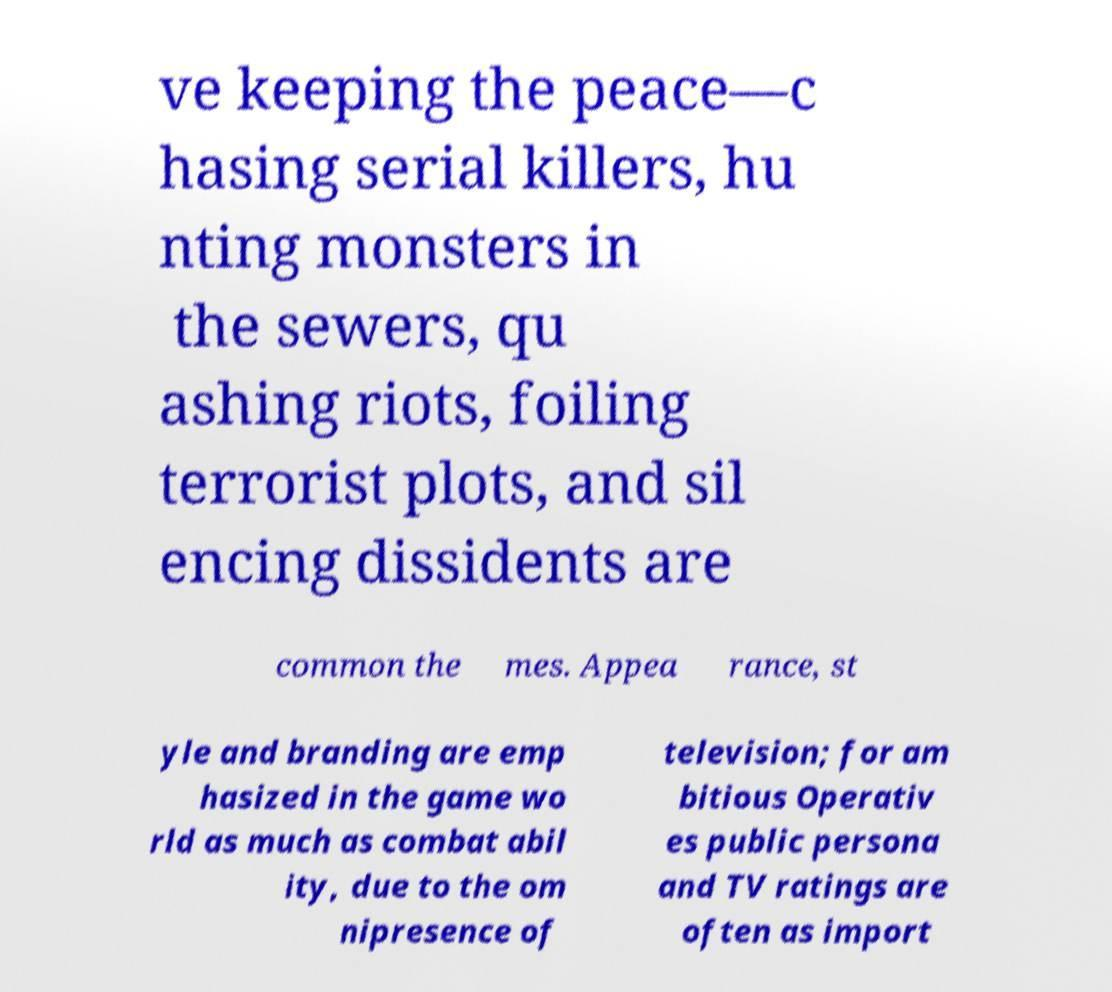Please identify and transcribe the text found in this image. ve keeping the peace—c hasing serial killers, hu nting monsters in the sewers, qu ashing riots, foiling terrorist plots, and sil encing dissidents are common the mes. Appea rance, st yle and branding are emp hasized in the game wo rld as much as combat abil ity, due to the om nipresence of television; for am bitious Operativ es public persona and TV ratings are often as import 